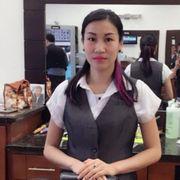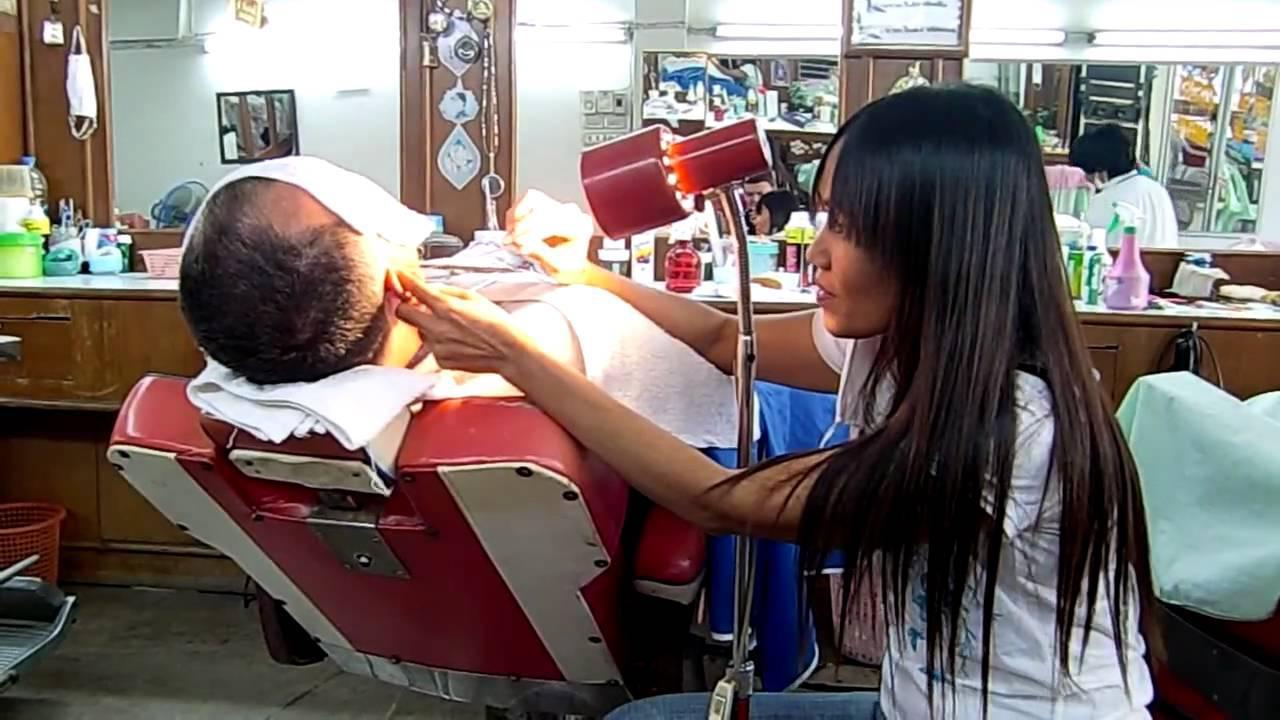The first image is the image on the left, the second image is the image on the right. Analyze the images presented: Is the assertion "Five humans are visible." valid? Answer yes or no. No. 